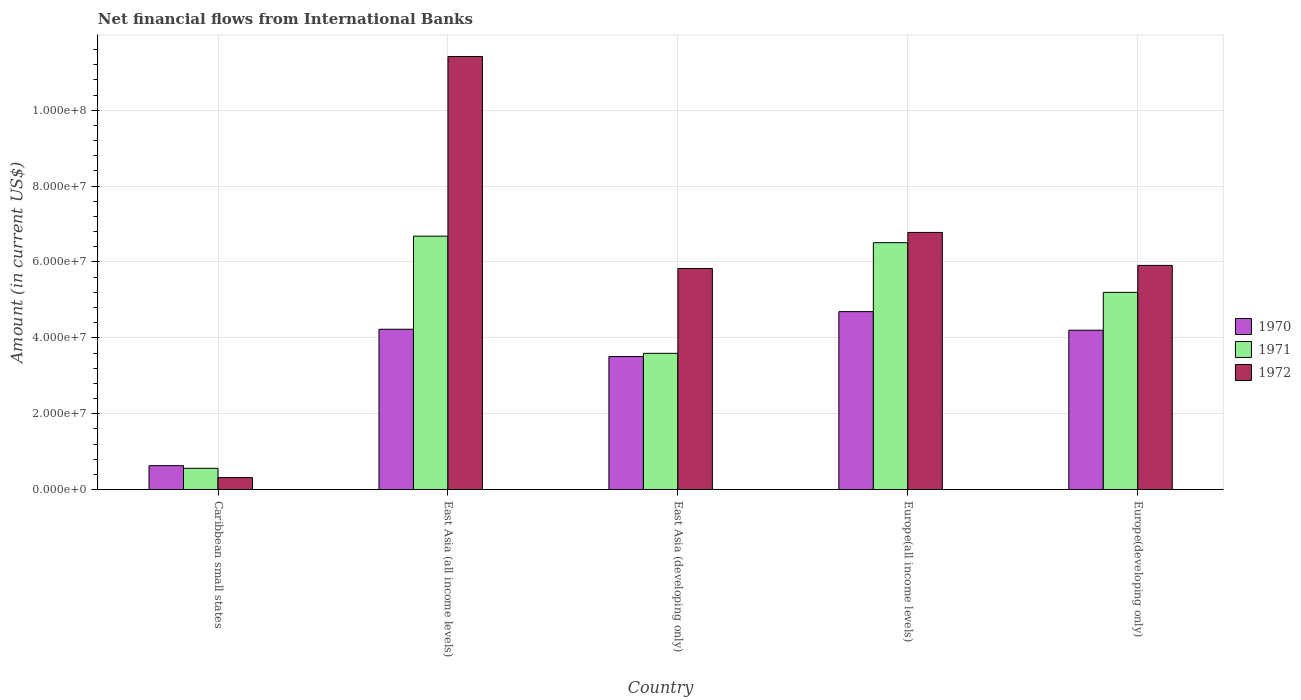How many different coloured bars are there?
Make the answer very short. 3. How many groups of bars are there?
Ensure brevity in your answer.  5. What is the label of the 3rd group of bars from the left?
Your answer should be compact. East Asia (developing only). In how many cases, is the number of bars for a given country not equal to the number of legend labels?
Offer a terse response. 0. What is the net financial aid flows in 1972 in Caribbean small states?
Your answer should be compact. 3.15e+06. Across all countries, what is the maximum net financial aid flows in 1970?
Keep it short and to the point. 4.69e+07. Across all countries, what is the minimum net financial aid flows in 1971?
Offer a very short reply. 5.60e+06. In which country was the net financial aid flows in 1971 maximum?
Your answer should be compact. East Asia (all income levels). In which country was the net financial aid flows in 1972 minimum?
Provide a succinct answer. Caribbean small states. What is the total net financial aid flows in 1970 in the graph?
Give a very brief answer. 1.73e+08. What is the difference between the net financial aid flows in 1972 in Caribbean small states and that in East Asia (all income levels)?
Your answer should be compact. -1.11e+08. What is the difference between the net financial aid flows in 1972 in Europe(all income levels) and the net financial aid flows in 1971 in Caribbean small states?
Keep it short and to the point. 6.22e+07. What is the average net financial aid flows in 1972 per country?
Keep it short and to the point. 6.05e+07. What is the difference between the net financial aid flows of/in 1972 and net financial aid flows of/in 1971 in Europe(all income levels)?
Provide a short and direct response. 2.70e+06. In how many countries, is the net financial aid flows in 1972 greater than 108000000 US$?
Keep it short and to the point. 1. What is the ratio of the net financial aid flows in 1972 in East Asia (developing only) to that in Europe(all income levels)?
Provide a succinct answer. 0.86. What is the difference between the highest and the second highest net financial aid flows in 1970?
Keep it short and to the point. 4.65e+06. What is the difference between the highest and the lowest net financial aid flows in 1971?
Your response must be concise. 6.12e+07. What does the 3rd bar from the left in Caribbean small states represents?
Your answer should be very brief. 1972. What does the 1st bar from the right in East Asia (all income levels) represents?
Ensure brevity in your answer.  1972. Is it the case that in every country, the sum of the net financial aid flows in 1971 and net financial aid flows in 1970 is greater than the net financial aid flows in 1972?
Your answer should be compact. No. Are all the bars in the graph horizontal?
Make the answer very short. No. How many countries are there in the graph?
Provide a succinct answer. 5. Does the graph contain any zero values?
Provide a short and direct response. No. Does the graph contain grids?
Keep it short and to the point. Yes. How many legend labels are there?
Your answer should be very brief. 3. What is the title of the graph?
Keep it short and to the point. Net financial flows from International Banks. Does "2013" appear as one of the legend labels in the graph?
Your response must be concise. No. What is the label or title of the X-axis?
Offer a very short reply. Country. What is the label or title of the Y-axis?
Make the answer very short. Amount (in current US$). What is the Amount (in current US$) of 1970 in Caribbean small states?
Offer a terse response. 6.30e+06. What is the Amount (in current US$) in 1971 in Caribbean small states?
Give a very brief answer. 5.60e+06. What is the Amount (in current US$) of 1972 in Caribbean small states?
Offer a terse response. 3.15e+06. What is the Amount (in current US$) in 1970 in East Asia (all income levels)?
Offer a terse response. 4.23e+07. What is the Amount (in current US$) in 1971 in East Asia (all income levels)?
Your answer should be compact. 6.68e+07. What is the Amount (in current US$) in 1972 in East Asia (all income levels)?
Ensure brevity in your answer.  1.14e+08. What is the Amount (in current US$) of 1970 in East Asia (developing only)?
Give a very brief answer. 3.51e+07. What is the Amount (in current US$) of 1971 in East Asia (developing only)?
Provide a succinct answer. 3.59e+07. What is the Amount (in current US$) of 1972 in East Asia (developing only)?
Offer a very short reply. 5.83e+07. What is the Amount (in current US$) of 1970 in Europe(all income levels)?
Provide a succinct answer. 4.69e+07. What is the Amount (in current US$) of 1971 in Europe(all income levels)?
Keep it short and to the point. 6.51e+07. What is the Amount (in current US$) in 1972 in Europe(all income levels)?
Your response must be concise. 6.78e+07. What is the Amount (in current US$) in 1970 in Europe(developing only)?
Offer a very short reply. 4.20e+07. What is the Amount (in current US$) of 1971 in Europe(developing only)?
Your response must be concise. 5.20e+07. What is the Amount (in current US$) in 1972 in Europe(developing only)?
Make the answer very short. 5.91e+07. Across all countries, what is the maximum Amount (in current US$) of 1970?
Provide a succinct answer. 4.69e+07. Across all countries, what is the maximum Amount (in current US$) in 1971?
Offer a very short reply. 6.68e+07. Across all countries, what is the maximum Amount (in current US$) of 1972?
Your answer should be very brief. 1.14e+08. Across all countries, what is the minimum Amount (in current US$) in 1970?
Your response must be concise. 6.30e+06. Across all countries, what is the minimum Amount (in current US$) in 1971?
Offer a terse response. 5.60e+06. Across all countries, what is the minimum Amount (in current US$) of 1972?
Provide a succinct answer. 3.15e+06. What is the total Amount (in current US$) of 1970 in the graph?
Give a very brief answer. 1.73e+08. What is the total Amount (in current US$) of 1971 in the graph?
Your response must be concise. 2.25e+08. What is the total Amount (in current US$) in 1972 in the graph?
Your answer should be very brief. 3.03e+08. What is the difference between the Amount (in current US$) of 1970 in Caribbean small states and that in East Asia (all income levels)?
Your answer should be compact. -3.60e+07. What is the difference between the Amount (in current US$) in 1971 in Caribbean small states and that in East Asia (all income levels)?
Ensure brevity in your answer.  -6.12e+07. What is the difference between the Amount (in current US$) in 1972 in Caribbean small states and that in East Asia (all income levels)?
Provide a short and direct response. -1.11e+08. What is the difference between the Amount (in current US$) in 1970 in Caribbean small states and that in East Asia (developing only)?
Your answer should be compact. -2.88e+07. What is the difference between the Amount (in current US$) of 1971 in Caribbean small states and that in East Asia (developing only)?
Provide a succinct answer. -3.03e+07. What is the difference between the Amount (in current US$) of 1972 in Caribbean small states and that in East Asia (developing only)?
Keep it short and to the point. -5.51e+07. What is the difference between the Amount (in current US$) in 1970 in Caribbean small states and that in Europe(all income levels)?
Your response must be concise. -4.06e+07. What is the difference between the Amount (in current US$) of 1971 in Caribbean small states and that in Europe(all income levels)?
Offer a very short reply. -5.95e+07. What is the difference between the Amount (in current US$) of 1972 in Caribbean small states and that in Europe(all income levels)?
Make the answer very short. -6.46e+07. What is the difference between the Amount (in current US$) of 1970 in Caribbean small states and that in Europe(developing only)?
Your answer should be compact. -3.57e+07. What is the difference between the Amount (in current US$) in 1971 in Caribbean small states and that in Europe(developing only)?
Make the answer very short. -4.64e+07. What is the difference between the Amount (in current US$) of 1972 in Caribbean small states and that in Europe(developing only)?
Provide a succinct answer. -5.59e+07. What is the difference between the Amount (in current US$) in 1970 in East Asia (all income levels) and that in East Asia (developing only)?
Make the answer very short. 7.20e+06. What is the difference between the Amount (in current US$) in 1971 in East Asia (all income levels) and that in East Asia (developing only)?
Make the answer very short. 3.09e+07. What is the difference between the Amount (in current US$) of 1972 in East Asia (all income levels) and that in East Asia (developing only)?
Your answer should be compact. 5.59e+07. What is the difference between the Amount (in current US$) in 1970 in East Asia (all income levels) and that in Europe(all income levels)?
Keep it short and to the point. -4.65e+06. What is the difference between the Amount (in current US$) in 1971 in East Asia (all income levels) and that in Europe(all income levels)?
Provide a succinct answer. 1.72e+06. What is the difference between the Amount (in current US$) in 1972 in East Asia (all income levels) and that in Europe(all income levels)?
Your answer should be compact. 4.64e+07. What is the difference between the Amount (in current US$) of 1970 in East Asia (all income levels) and that in Europe(developing only)?
Provide a succinct answer. 2.48e+05. What is the difference between the Amount (in current US$) in 1971 in East Asia (all income levels) and that in Europe(developing only)?
Your answer should be very brief. 1.48e+07. What is the difference between the Amount (in current US$) in 1972 in East Asia (all income levels) and that in Europe(developing only)?
Your answer should be very brief. 5.51e+07. What is the difference between the Amount (in current US$) of 1970 in East Asia (developing only) and that in Europe(all income levels)?
Ensure brevity in your answer.  -1.19e+07. What is the difference between the Amount (in current US$) in 1971 in East Asia (developing only) and that in Europe(all income levels)?
Provide a short and direct response. -2.92e+07. What is the difference between the Amount (in current US$) in 1972 in East Asia (developing only) and that in Europe(all income levels)?
Your answer should be very brief. -9.52e+06. What is the difference between the Amount (in current US$) of 1970 in East Asia (developing only) and that in Europe(developing only)?
Keep it short and to the point. -6.95e+06. What is the difference between the Amount (in current US$) of 1971 in East Asia (developing only) and that in Europe(developing only)?
Ensure brevity in your answer.  -1.61e+07. What is the difference between the Amount (in current US$) of 1972 in East Asia (developing only) and that in Europe(developing only)?
Ensure brevity in your answer.  -8.15e+05. What is the difference between the Amount (in current US$) of 1970 in Europe(all income levels) and that in Europe(developing only)?
Your answer should be very brief. 4.90e+06. What is the difference between the Amount (in current US$) of 1971 in Europe(all income levels) and that in Europe(developing only)?
Your answer should be very brief. 1.31e+07. What is the difference between the Amount (in current US$) of 1972 in Europe(all income levels) and that in Europe(developing only)?
Offer a terse response. 8.70e+06. What is the difference between the Amount (in current US$) in 1970 in Caribbean small states and the Amount (in current US$) in 1971 in East Asia (all income levels)?
Ensure brevity in your answer.  -6.05e+07. What is the difference between the Amount (in current US$) in 1970 in Caribbean small states and the Amount (in current US$) in 1972 in East Asia (all income levels)?
Your response must be concise. -1.08e+08. What is the difference between the Amount (in current US$) of 1971 in Caribbean small states and the Amount (in current US$) of 1972 in East Asia (all income levels)?
Ensure brevity in your answer.  -1.09e+08. What is the difference between the Amount (in current US$) of 1970 in Caribbean small states and the Amount (in current US$) of 1971 in East Asia (developing only)?
Ensure brevity in your answer.  -2.96e+07. What is the difference between the Amount (in current US$) in 1970 in Caribbean small states and the Amount (in current US$) in 1972 in East Asia (developing only)?
Provide a succinct answer. -5.20e+07. What is the difference between the Amount (in current US$) in 1971 in Caribbean small states and the Amount (in current US$) in 1972 in East Asia (developing only)?
Ensure brevity in your answer.  -5.27e+07. What is the difference between the Amount (in current US$) of 1970 in Caribbean small states and the Amount (in current US$) of 1971 in Europe(all income levels)?
Provide a succinct answer. -5.88e+07. What is the difference between the Amount (in current US$) in 1970 in Caribbean small states and the Amount (in current US$) in 1972 in Europe(all income levels)?
Offer a terse response. -6.15e+07. What is the difference between the Amount (in current US$) in 1971 in Caribbean small states and the Amount (in current US$) in 1972 in Europe(all income levels)?
Your response must be concise. -6.22e+07. What is the difference between the Amount (in current US$) in 1970 in Caribbean small states and the Amount (in current US$) in 1971 in Europe(developing only)?
Offer a terse response. -4.57e+07. What is the difference between the Amount (in current US$) in 1970 in Caribbean small states and the Amount (in current US$) in 1972 in Europe(developing only)?
Give a very brief answer. -5.28e+07. What is the difference between the Amount (in current US$) of 1971 in Caribbean small states and the Amount (in current US$) of 1972 in Europe(developing only)?
Offer a terse response. -5.35e+07. What is the difference between the Amount (in current US$) of 1970 in East Asia (all income levels) and the Amount (in current US$) of 1971 in East Asia (developing only)?
Offer a terse response. 6.34e+06. What is the difference between the Amount (in current US$) in 1970 in East Asia (all income levels) and the Amount (in current US$) in 1972 in East Asia (developing only)?
Your answer should be very brief. -1.60e+07. What is the difference between the Amount (in current US$) of 1971 in East Asia (all income levels) and the Amount (in current US$) of 1972 in East Asia (developing only)?
Your answer should be very brief. 8.53e+06. What is the difference between the Amount (in current US$) in 1970 in East Asia (all income levels) and the Amount (in current US$) in 1971 in Europe(all income levels)?
Offer a terse response. -2.28e+07. What is the difference between the Amount (in current US$) of 1970 in East Asia (all income levels) and the Amount (in current US$) of 1972 in Europe(all income levels)?
Make the answer very short. -2.55e+07. What is the difference between the Amount (in current US$) of 1971 in East Asia (all income levels) and the Amount (in current US$) of 1972 in Europe(all income levels)?
Your answer should be compact. -9.81e+05. What is the difference between the Amount (in current US$) of 1970 in East Asia (all income levels) and the Amount (in current US$) of 1971 in Europe(developing only)?
Give a very brief answer. -9.73e+06. What is the difference between the Amount (in current US$) of 1970 in East Asia (all income levels) and the Amount (in current US$) of 1972 in Europe(developing only)?
Ensure brevity in your answer.  -1.68e+07. What is the difference between the Amount (in current US$) in 1971 in East Asia (all income levels) and the Amount (in current US$) in 1972 in Europe(developing only)?
Make the answer very short. 7.72e+06. What is the difference between the Amount (in current US$) of 1970 in East Asia (developing only) and the Amount (in current US$) of 1971 in Europe(all income levels)?
Offer a very short reply. -3.00e+07. What is the difference between the Amount (in current US$) of 1970 in East Asia (developing only) and the Amount (in current US$) of 1972 in Europe(all income levels)?
Your answer should be compact. -3.27e+07. What is the difference between the Amount (in current US$) of 1971 in East Asia (developing only) and the Amount (in current US$) of 1972 in Europe(all income levels)?
Provide a succinct answer. -3.19e+07. What is the difference between the Amount (in current US$) in 1970 in East Asia (developing only) and the Amount (in current US$) in 1971 in Europe(developing only)?
Give a very brief answer. -1.69e+07. What is the difference between the Amount (in current US$) of 1970 in East Asia (developing only) and the Amount (in current US$) of 1972 in Europe(developing only)?
Ensure brevity in your answer.  -2.40e+07. What is the difference between the Amount (in current US$) of 1971 in East Asia (developing only) and the Amount (in current US$) of 1972 in Europe(developing only)?
Your answer should be very brief. -2.32e+07. What is the difference between the Amount (in current US$) of 1970 in Europe(all income levels) and the Amount (in current US$) of 1971 in Europe(developing only)?
Provide a succinct answer. -5.08e+06. What is the difference between the Amount (in current US$) of 1970 in Europe(all income levels) and the Amount (in current US$) of 1972 in Europe(developing only)?
Your answer should be very brief. -1.22e+07. What is the difference between the Amount (in current US$) in 1971 in Europe(all income levels) and the Amount (in current US$) in 1972 in Europe(developing only)?
Give a very brief answer. 6.00e+06. What is the average Amount (in current US$) of 1970 per country?
Offer a very short reply. 3.45e+07. What is the average Amount (in current US$) in 1971 per country?
Offer a terse response. 4.51e+07. What is the average Amount (in current US$) of 1972 per country?
Keep it short and to the point. 6.05e+07. What is the difference between the Amount (in current US$) of 1970 and Amount (in current US$) of 1971 in Caribbean small states?
Your answer should be very brief. 6.96e+05. What is the difference between the Amount (in current US$) of 1970 and Amount (in current US$) of 1972 in Caribbean small states?
Give a very brief answer. 3.15e+06. What is the difference between the Amount (in current US$) of 1971 and Amount (in current US$) of 1972 in Caribbean small states?
Provide a short and direct response. 2.45e+06. What is the difference between the Amount (in current US$) in 1970 and Amount (in current US$) in 1971 in East Asia (all income levels)?
Make the answer very short. -2.46e+07. What is the difference between the Amount (in current US$) of 1970 and Amount (in current US$) of 1972 in East Asia (all income levels)?
Provide a short and direct response. -7.19e+07. What is the difference between the Amount (in current US$) in 1971 and Amount (in current US$) in 1972 in East Asia (all income levels)?
Provide a short and direct response. -4.74e+07. What is the difference between the Amount (in current US$) of 1970 and Amount (in current US$) of 1971 in East Asia (developing only)?
Give a very brief answer. -8.55e+05. What is the difference between the Amount (in current US$) in 1970 and Amount (in current US$) in 1972 in East Asia (developing only)?
Offer a terse response. -2.32e+07. What is the difference between the Amount (in current US$) in 1971 and Amount (in current US$) in 1972 in East Asia (developing only)?
Make the answer very short. -2.24e+07. What is the difference between the Amount (in current US$) of 1970 and Amount (in current US$) of 1971 in Europe(all income levels)?
Offer a very short reply. -1.82e+07. What is the difference between the Amount (in current US$) of 1970 and Amount (in current US$) of 1972 in Europe(all income levels)?
Give a very brief answer. -2.09e+07. What is the difference between the Amount (in current US$) in 1971 and Amount (in current US$) in 1972 in Europe(all income levels)?
Give a very brief answer. -2.70e+06. What is the difference between the Amount (in current US$) in 1970 and Amount (in current US$) in 1971 in Europe(developing only)?
Offer a very short reply. -9.98e+06. What is the difference between the Amount (in current US$) of 1970 and Amount (in current US$) of 1972 in Europe(developing only)?
Your answer should be very brief. -1.71e+07. What is the difference between the Amount (in current US$) in 1971 and Amount (in current US$) in 1972 in Europe(developing only)?
Make the answer very short. -7.10e+06. What is the ratio of the Amount (in current US$) in 1970 in Caribbean small states to that in East Asia (all income levels)?
Your answer should be very brief. 0.15. What is the ratio of the Amount (in current US$) in 1971 in Caribbean small states to that in East Asia (all income levels)?
Your answer should be very brief. 0.08. What is the ratio of the Amount (in current US$) of 1972 in Caribbean small states to that in East Asia (all income levels)?
Provide a short and direct response. 0.03. What is the ratio of the Amount (in current US$) of 1970 in Caribbean small states to that in East Asia (developing only)?
Offer a terse response. 0.18. What is the ratio of the Amount (in current US$) of 1971 in Caribbean small states to that in East Asia (developing only)?
Keep it short and to the point. 0.16. What is the ratio of the Amount (in current US$) of 1972 in Caribbean small states to that in East Asia (developing only)?
Your response must be concise. 0.05. What is the ratio of the Amount (in current US$) of 1970 in Caribbean small states to that in Europe(all income levels)?
Give a very brief answer. 0.13. What is the ratio of the Amount (in current US$) in 1971 in Caribbean small states to that in Europe(all income levels)?
Provide a short and direct response. 0.09. What is the ratio of the Amount (in current US$) in 1972 in Caribbean small states to that in Europe(all income levels)?
Provide a succinct answer. 0.05. What is the ratio of the Amount (in current US$) of 1970 in Caribbean small states to that in Europe(developing only)?
Keep it short and to the point. 0.15. What is the ratio of the Amount (in current US$) of 1971 in Caribbean small states to that in Europe(developing only)?
Offer a very short reply. 0.11. What is the ratio of the Amount (in current US$) in 1972 in Caribbean small states to that in Europe(developing only)?
Offer a very short reply. 0.05. What is the ratio of the Amount (in current US$) in 1970 in East Asia (all income levels) to that in East Asia (developing only)?
Your response must be concise. 1.21. What is the ratio of the Amount (in current US$) in 1971 in East Asia (all income levels) to that in East Asia (developing only)?
Give a very brief answer. 1.86. What is the ratio of the Amount (in current US$) of 1972 in East Asia (all income levels) to that in East Asia (developing only)?
Offer a terse response. 1.96. What is the ratio of the Amount (in current US$) of 1970 in East Asia (all income levels) to that in Europe(all income levels)?
Your answer should be compact. 0.9. What is the ratio of the Amount (in current US$) of 1971 in East Asia (all income levels) to that in Europe(all income levels)?
Make the answer very short. 1.03. What is the ratio of the Amount (in current US$) of 1972 in East Asia (all income levels) to that in Europe(all income levels)?
Your response must be concise. 1.68. What is the ratio of the Amount (in current US$) of 1970 in East Asia (all income levels) to that in Europe(developing only)?
Your answer should be very brief. 1.01. What is the ratio of the Amount (in current US$) of 1971 in East Asia (all income levels) to that in Europe(developing only)?
Your response must be concise. 1.29. What is the ratio of the Amount (in current US$) in 1972 in East Asia (all income levels) to that in Europe(developing only)?
Keep it short and to the point. 1.93. What is the ratio of the Amount (in current US$) in 1970 in East Asia (developing only) to that in Europe(all income levels)?
Provide a succinct answer. 0.75. What is the ratio of the Amount (in current US$) in 1971 in East Asia (developing only) to that in Europe(all income levels)?
Ensure brevity in your answer.  0.55. What is the ratio of the Amount (in current US$) in 1972 in East Asia (developing only) to that in Europe(all income levels)?
Offer a very short reply. 0.86. What is the ratio of the Amount (in current US$) of 1970 in East Asia (developing only) to that in Europe(developing only)?
Offer a very short reply. 0.83. What is the ratio of the Amount (in current US$) of 1971 in East Asia (developing only) to that in Europe(developing only)?
Ensure brevity in your answer.  0.69. What is the ratio of the Amount (in current US$) in 1972 in East Asia (developing only) to that in Europe(developing only)?
Provide a succinct answer. 0.99. What is the ratio of the Amount (in current US$) in 1970 in Europe(all income levels) to that in Europe(developing only)?
Your answer should be very brief. 1.12. What is the ratio of the Amount (in current US$) of 1971 in Europe(all income levels) to that in Europe(developing only)?
Offer a terse response. 1.25. What is the ratio of the Amount (in current US$) in 1972 in Europe(all income levels) to that in Europe(developing only)?
Provide a succinct answer. 1.15. What is the difference between the highest and the second highest Amount (in current US$) in 1970?
Offer a very short reply. 4.65e+06. What is the difference between the highest and the second highest Amount (in current US$) in 1971?
Keep it short and to the point. 1.72e+06. What is the difference between the highest and the second highest Amount (in current US$) in 1972?
Keep it short and to the point. 4.64e+07. What is the difference between the highest and the lowest Amount (in current US$) of 1970?
Give a very brief answer. 4.06e+07. What is the difference between the highest and the lowest Amount (in current US$) of 1971?
Give a very brief answer. 6.12e+07. What is the difference between the highest and the lowest Amount (in current US$) in 1972?
Keep it short and to the point. 1.11e+08. 